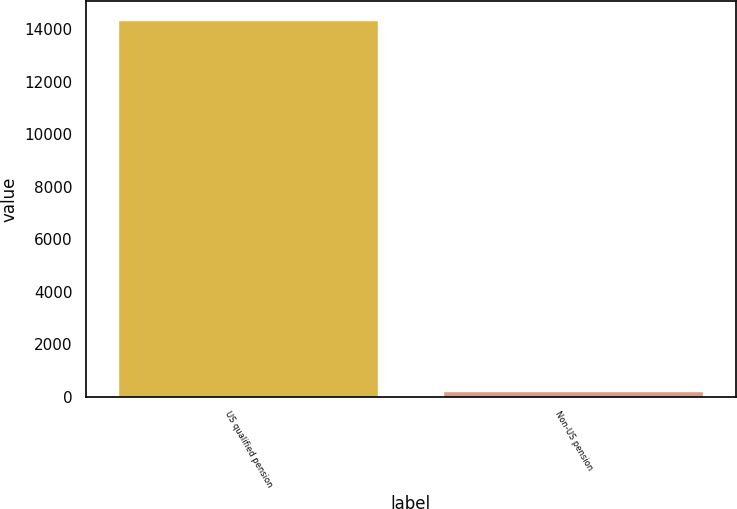Convert chart to OTSL. <chart><loc_0><loc_0><loc_500><loc_500><bar_chart><fcel>US qualified pension<fcel>Non-US pension<nl><fcel>14343<fcel>233<nl></chart> 